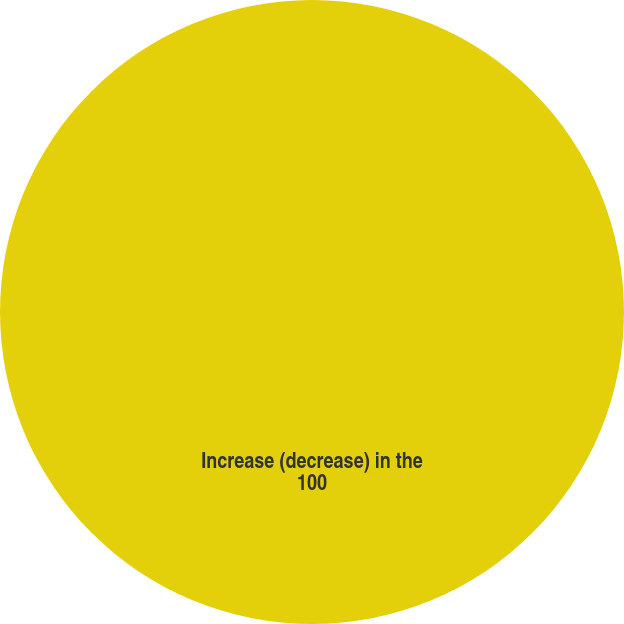Convert chart to OTSL. <chart><loc_0><loc_0><loc_500><loc_500><pie_chart><fcel>Increase (decrease) in the<nl><fcel>100.0%<nl></chart> 